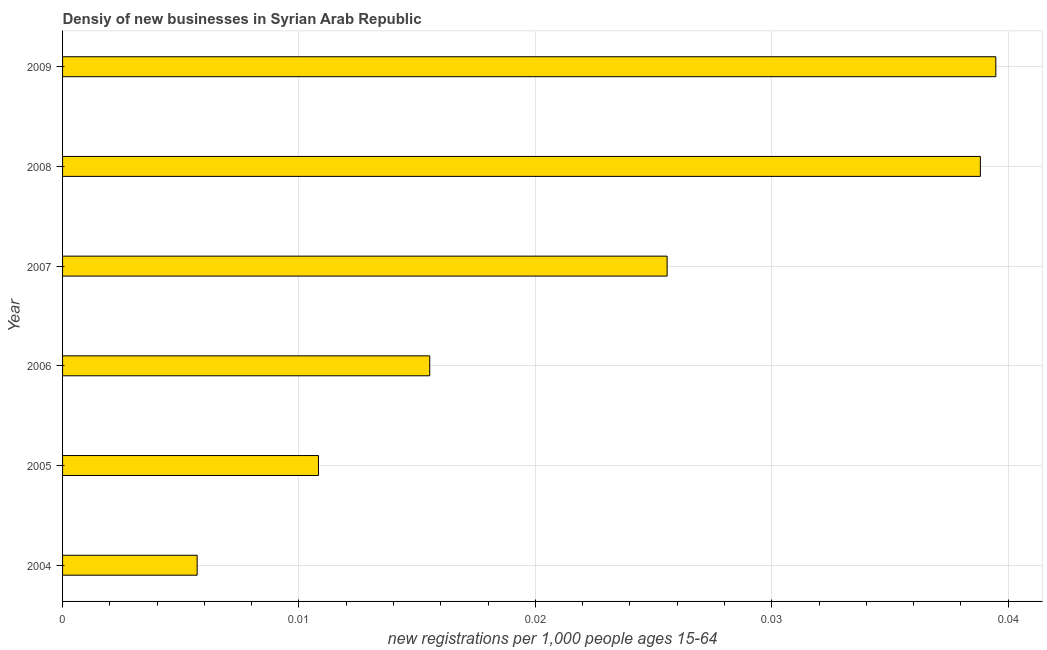Does the graph contain any zero values?
Provide a short and direct response. No. Does the graph contain grids?
Offer a very short reply. Yes. What is the title of the graph?
Give a very brief answer. Densiy of new businesses in Syrian Arab Republic. What is the label or title of the X-axis?
Provide a short and direct response. New registrations per 1,0 people ages 15-64. What is the label or title of the Y-axis?
Offer a very short reply. Year. What is the density of new business in 2005?
Ensure brevity in your answer.  0.01. Across all years, what is the maximum density of new business?
Provide a short and direct response. 0.04. Across all years, what is the minimum density of new business?
Provide a short and direct response. 0.01. What is the sum of the density of new business?
Ensure brevity in your answer.  0.14. What is the difference between the density of new business in 2004 and 2008?
Your answer should be compact. -0.03. What is the average density of new business per year?
Make the answer very short. 0.02. What is the median density of new business?
Make the answer very short. 0.02. In how many years, is the density of new business greater than 0.022 ?
Keep it short and to the point. 3. Do a majority of the years between 2007 and 2004 (inclusive) have density of new business greater than 0.026 ?
Keep it short and to the point. Yes. What is the ratio of the density of new business in 2008 to that in 2009?
Offer a terse response. 0.98. What is the difference between the highest and the second highest density of new business?
Provide a succinct answer. 0. Is the sum of the density of new business in 2004 and 2006 greater than the maximum density of new business across all years?
Give a very brief answer. No. What is the difference between the highest and the lowest density of new business?
Your answer should be very brief. 0.03. How many bars are there?
Your answer should be very brief. 6. Are all the bars in the graph horizontal?
Your response must be concise. Yes. What is the difference between two consecutive major ticks on the X-axis?
Provide a short and direct response. 0.01. Are the values on the major ticks of X-axis written in scientific E-notation?
Provide a succinct answer. No. What is the new registrations per 1,000 people ages 15-64 of 2004?
Provide a succinct answer. 0.01. What is the new registrations per 1,000 people ages 15-64 of 2005?
Keep it short and to the point. 0.01. What is the new registrations per 1,000 people ages 15-64 of 2006?
Your answer should be very brief. 0.02. What is the new registrations per 1,000 people ages 15-64 in 2007?
Offer a very short reply. 0.03. What is the new registrations per 1,000 people ages 15-64 in 2008?
Your answer should be very brief. 0.04. What is the new registrations per 1,000 people ages 15-64 in 2009?
Your answer should be compact. 0.04. What is the difference between the new registrations per 1,000 people ages 15-64 in 2004 and 2005?
Make the answer very short. -0.01. What is the difference between the new registrations per 1,000 people ages 15-64 in 2004 and 2006?
Keep it short and to the point. -0.01. What is the difference between the new registrations per 1,000 people ages 15-64 in 2004 and 2007?
Your answer should be very brief. -0.02. What is the difference between the new registrations per 1,000 people ages 15-64 in 2004 and 2008?
Ensure brevity in your answer.  -0.03. What is the difference between the new registrations per 1,000 people ages 15-64 in 2004 and 2009?
Your answer should be compact. -0.03. What is the difference between the new registrations per 1,000 people ages 15-64 in 2005 and 2006?
Offer a terse response. -0. What is the difference between the new registrations per 1,000 people ages 15-64 in 2005 and 2007?
Give a very brief answer. -0.01. What is the difference between the new registrations per 1,000 people ages 15-64 in 2005 and 2008?
Offer a terse response. -0.03. What is the difference between the new registrations per 1,000 people ages 15-64 in 2005 and 2009?
Give a very brief answer. -0.03. What is the difference between the new registrations per 1,000 people ages 15-64 in 2006 and 2007?
Provide a short and direct response. -0.01. What is the difference between the new registrations per 1,000 people ages 15-64 in 2006 and 2008?
Your response must be concise. -0.02. What is the difference between the new registrations per 1,000 people ages 15-64 in 2006 and 2009?
Ensure brevity in your answer.  -0.02. What is the difference between the new registrations per 1,000 people ages 15-64 in 2007 and 2008?
Your answer should be compact. -0.01. What is the difference between the new registrations per 1,000 people ages 15-64 in 2007 and 2009?
Your answer should be compact. -0.01. What is the difference between the new registrations per 1,000 people ages 15-64 in 2008 and 2009?
Offer a very short reply. -0. What is the ratio of the new registrations per 1,000 people ages 15-64 in 2004 to that in 2005?
Your answer should be very brief. 0.53. What is the ratio of the new registrations per 1,000 people ages 15-64 in 2004 to that in 2006?
Offer a terse response. 0.37. What is the ratio of the new registrations per 1,000 people ages 15-64 in 2004 to that in 2007?
Make the answer very short. 0.22. What is the ratio of the new registrations per 1,000 people ages 15-64 in 2004 to that in 2008?
Ensure brevity in your answer.  0.15. What is the ratio of the new registrations per 1,000 people ages 15-64 in 2004 to that in 2009?
Make the answer very short. 0.14. What is the ratio of the new registrations per 1,000 people ages 15-64 in 2005 to that in 2006?
Offer a very short reply. 0.7. What is the ratio of the new registrations per 1,000 people ages 15-64 in 2005 to that in 2007?
Offer a very short reply. 0.42. What is the ratio of the new registrations per 1,000 people ages 15-64 in 2005 to that in 2008?
Give a very brief answer. 0.28. What is the ratio of the new registrations per 1,000 people ages 15-64 in 2005 to that in 2009?
Your answer should be very brief. 0.27. What is the ratio of the new registrations per 1,000 people ages 15-64 in 2006 to that in 2007?
Provide a short and direct response. 0.61. What is the ratio of the new registrations per 1,000 people ages 15-64 in 2006 to that in 2008?
Make the answer very short. 0.4. What is the ratio of the new registrations per 1,000 people ages 15-64 in 2006 to that in 2009?
Provide a succinct answer. 0.39. What is the ratio of the new registrations per 1,000 people ages 15-64 in 2007 to that in 2008?
Offer a very short reply. 0.66. What is the ratio of the new registrations per 1,000 people ages 15-64 in 2007 to that in 2009?
Offer a very short reply. 0.65. 